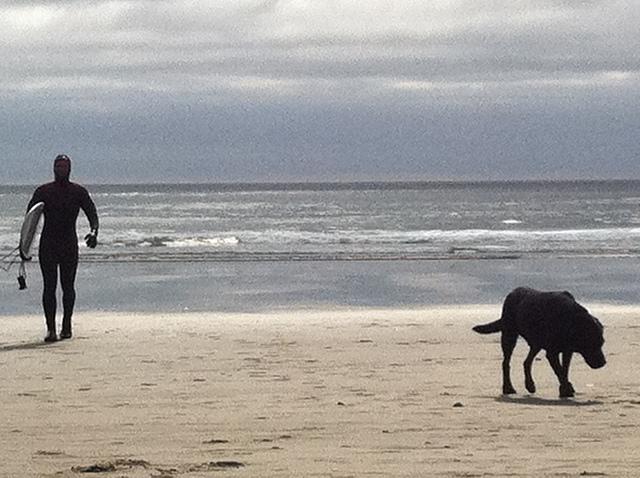Is there a dog?
Quick response, please. Yes. What is the breed of the dog?
Answer briefly. Lab. What is in front of the dog?
Short answer required. Sand. How many people are in the photo?
Answer briefly. 1. What is the dog carrying?
Answer briefly. Nothing. What is the man walking towards?
Quick response, please. Camera. Where are they?
Give a very brief answer. Beach. Who is in the beach?
Short answer required. Man and dog. What color is the collar?
Concise answer only. Black. 